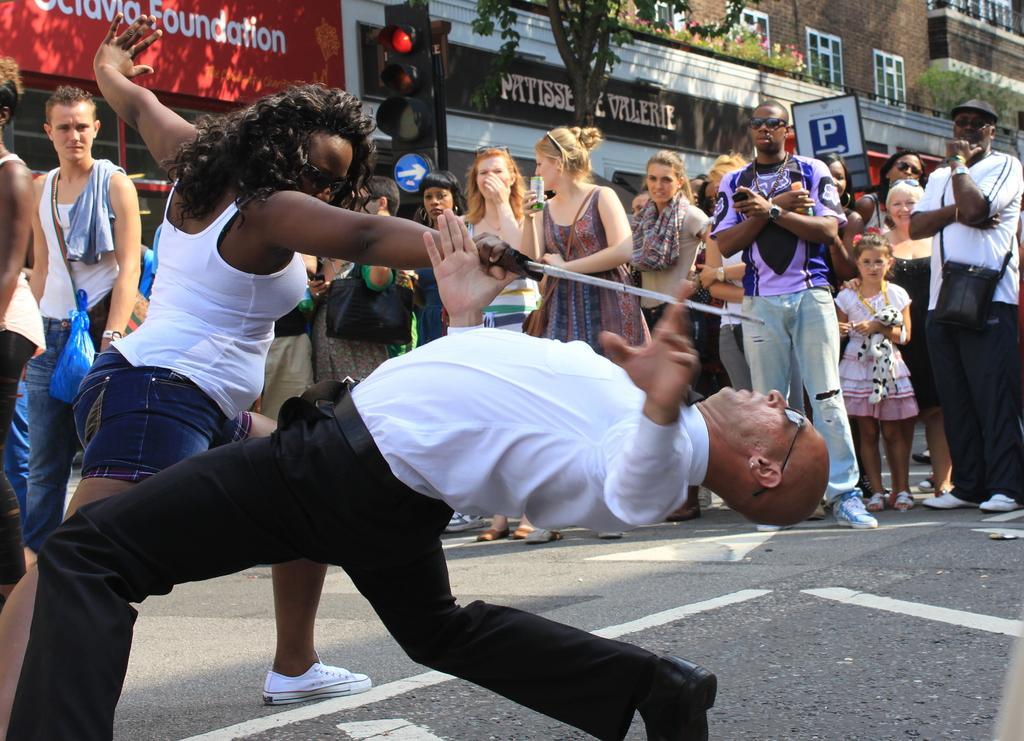Please provide a concise description of this image. In this image there is a women holding a knife and doing some activity, in front of the women a man is bending, in the background there are people and shops and there is a signal pole and a board. 